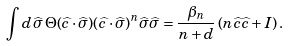<formula> <loc_0><loc_0><loc_500><loc_500>\int d \widehat { \sigma } \, \Theta ( \widehat { c } \cdot \widehat { \sigma } ) ( \widehat { c } \cdot \widehat { \sigma } ) ^ { n } \widehat { \sigma } \widehat { \sigma } = \frac { \beta _ { n } } { n + d } \left ( n \widehat { c } \widehat { c } + I \right ) .</formula> 